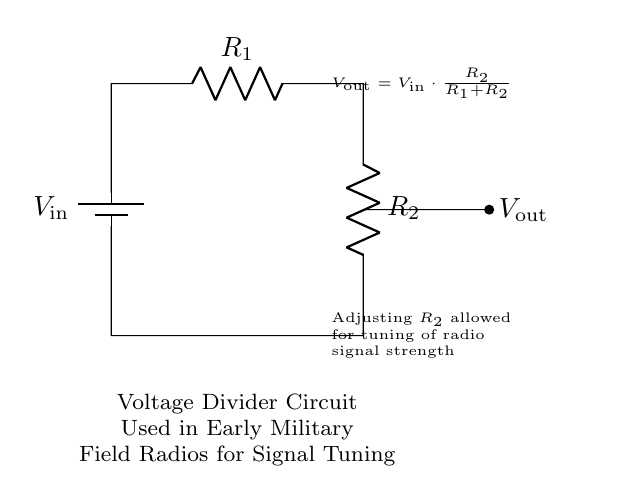What is the input voltage of this circuit? The input voltage is labeled as V_in, which is attached to the positive terminal of the battery in the circuit diagram.
Answer: V_in What are the two resistors in this circuit? The two resistors are labeled as R₁ and R₂, which are connected in series. R₁ is at the top, and R₂ is at the bottom of the diagram.
Answer: R₁ and R₂ What is the output voltage formula used in this circuit? The output voltage V_out is calculated using the formula V_out = V_in * (R₂ / (R₁ + R₂)), which relates the input voltage and the resistance values.
Answer: V_out = V_in * (R₂ / (R₁ + R₂)) How does adjusting R₂ affect the radio signal? Adjusting R₂ changes the ratio of the voltage divider, allowing for tuning of the output voltage and thereby affecting the strength of the radio signal.
Answer: It allows tuning What is the purpose of this voltage divider circuit? The purpose is to divide the input voltage to create a lower output voltage, which is used for signal tuning in early military field radios.
Answer: Signal tuning Which component determines the output voltage along with R₂? R₁ determines the output voltage in conjunction with R₂, as both resistors form the voltage divider, influencing V_out based on their values.
Answer: R₁ 